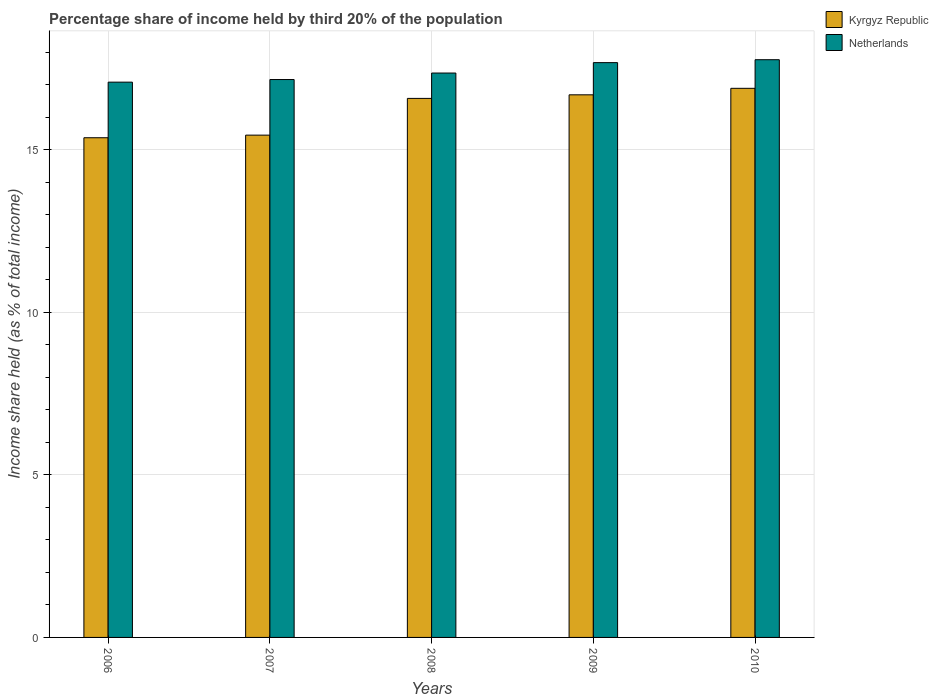How many different coloured bars are there?
Your answer should be very brief. 2. Are the number of bars per tick equal to the number of legend labels?
Provide a short and direct response. Yes. Are the number of bars on each tick of the X-axis equal?
Your answer should be compact. Yes. How many bars are there on the 2nd tick from the left?
Provide a short and direct response. 2. What is the share of income held by third 20% of the population in Netherlands in 2009?
Offer a very short reply. 17.68. Across all years, what is the maximum share of income held by third 20% of the population in Netherlands?
Offer a terse response. 17.77. Across all years, what is the minimum share of income held by third 20% of the population in Netherlands?
Provide a short and direct response. 17.08. In which year was the share of income held by third 20% of the population in Kyrgyz Republic maximum?
Provide a short and direct response. 2010. In which year was the share of income held by third 20% of the population in Kyrgyz Republic minimum?
Give a very brief answer. 2006. What is the total share of income held by third 20% of the population in Kyrgyz Republic in the graph?
Your answer should be very brief. 80.98. What is the difference between the share of income held by third 20% of the population in Netherlands in 2007 and that in 2009?
Keep it short and to the point. -0.52. What is the difference between the share of income held by third 20% of the population in Netherlands in 2007 and the share of income held by third 20% of the population in Kyrgyz Republic in 2006?
Provide a short and direct response. 1.79. What is the average share of income held by third 20% of the population in Kyrgyz Republic per year?
Offer a very short reply. 16.2. In the year 2010, what is the difference between the share of income held by third 20% of the population in Kyrgyz Republic and share of income held by third 20% of the population in Netherlands?
Provide a succinct answer. -0.88. What is the ratio of the share of income held by third 20% of the population in Kyrgyz Republic in 2007 to that in 2008?
Your answer should be compact. 0.93. Is the difference between the share of income held by third 20% of the population in Kyrgyz Republic in 2006 and 2009 greater than the difference between the share of income held by third 20% of the population in Netherlands in 2006 and 2009?
Give a very brief answer. No. What is the difference between the highest and the second highest share of income held by third 20% of the population in Kyrgyz Republic?
Provide a succinct answer. 0.2. What is the difference between the highest and the lowest share of income held by third 20% of the population in Netherlands?
Ensure brevity in your answer.  0.69. What does the 1st bar from the left in 2009 represents?
Offer a terse response. Kyrgyz Republic. How many bars are there?
Your answer should be compact. 10. How many years are there in the graph?
Ensure brevity in your answer.  5. Does the graph contain any zero values?
Your answer should be very brief. No. Does the graph contain grids?
Ensure brevity in your answer.  Yes. Where does the legend appear in the graph?
Give a very brief answer. Top right. How are the legend labels stacked?
Your response must be concise. Vertical. What is the title of the graph?
Offer a terse response. Percentage share of income held by third 20% of the population. Does "Samoa" appear as one of the legend labels in the graph?
Provide a succinct answer. No. What is the label or title of the X-axis?
Your answer should be very brief. Years. What is the label or title of the Y-axis?
Your answer should be very brief. Income share held (as % of total income). What is the Income share held (as % of total income) of Kyrgyz Republic in 2006?
Offer a terse response. 15.37. What is the Income share held (as % of total income) in Netherlands in 2006?
Your response must be concise. 17.08. What is the Income share held (as % of total income) of Kyrgyz Republic in 2007?
Keep it short and to the point. 15.45. What is the Income share held (as % of total income) of Netherlands in 2007?
Provide a succinct answer. 17.16. What is the Income share held (as % of total income) of Kyrgyz Republic in 2008?
Make the answer very short. 16.58. What is the Income share held (as % of total income) in Netherlands in 2008?
Give a very brief answer. 17.36. What is the Income share held (as % of total income) in Kyrgyz Republic in 2009?
Keep it short and to the point. 16.69. What is the Income share held (as % of total income) in Netherlands in 2009?
Your answer should be compact. 17.68. What is the Income share held (as % of total income) in Kyrgyz Republic in 2010?
Offer a terse response. 16.89. What is the Income share held (as % of total income) of Netherlands in 2010?
Offer a very short reply. 17.77. Across all years, what is the maximum Income share held (as % of total income) in Kyrgyz Republic?
Keep it short and to the point. 16.89. Across all years, what is the maximum Income share held (as % of total income) of Netherlands?
Your answer should be very brief. 17.77. Across all years, what is the minimum Income share held (as % of total income) in Kyrgyz Republic?
Ensure brevity in your answer.  15.37. Across all years, what is the minimum Income share held (as % of total income) of Netherlands?
Ensure brevity in your answer.  17.08. What is the total Income share held (as % of total income) in Kyrgyz Republic in the graph?
Offer a very short reply. 80.98. What is the total Income share held (as % of total income) of Netherlands in the graph?
Your answer should be compact. 87.05. What is the difference between the Income share held (as % of total income) of Kyrgyz Republic in 2006 and that in 2007?
Keep it short and to the point. -0.08. What is the difference between the Income share held (as % of total income) in Netherlands in 2006 and that in 2007?
Keep it short and to the point. -0.08. What is the difference between the Income share held (as % of total income) of Kyrgyz Republic in 2006 and that in 2008?
Keep it short and to the point. -1.21. What is the difference between the Income share held (as % of total income) of Netherlands in 2006 and that in 2008?
Offer a very short reply. -0.28. What is the difference between the Income share held (as % of total income) in Kyrgyz Republic in 2006 and that in 2009?
Provide a short and direct response. -1.32. What is the difference between the Income share held (as % of total income) of Kyrgyz Republic in 2006 and that in 2010?
Make the answer very short. -1.52. What is the difference between the Income share held (as % of total income) of Netherlands in 2006 and that in 2010?
Ensure brevity in your answer.  -0.69. What is the difference between the Income share held (as % of total income) in Kyrgyz Republic in 2007 and that in 2008?
Provide a short and direct response. -1.13. What is the difference between the Income share held (as % of total income) in Kyrgyz Republic in 2007 and that in 2009?
Your answer should be compact. -1.24. What is the difference between the Income share held (as % of total income) in Netherlands in 2007 and that in 2009?
Provide a short and direct response. -0.52. What is the difference between the Income share held (as % of total income) of Kyrgyz Republic in 2007 and that in 2010?
Offer a terse response. -1.44. What is the difference between the Income share held (as % of total income) of Netherlands in 2007 and that in 2010?
Your answer should be very brief. -0.61. What is the difference between the Income share held (as % of total income) in Kyrgyz Republic in 2008 and that in 2009?
Ensure brevity in your answer.  -0.11. What is the difference between the Income share held (as % of total income) in Netherlands in 2008 and that in 2009?
Make the answer very short. -0.32. What is the difference between the Income share held (as % of total income) in Kyrgyz Republic in 2008 and that in 2010?
Provide a short and direct response. -0.31. What is the difference between the Income share held (as % of total income) of Netherlands in 2008 and that in 2010?
Offer a terse response. -0.41. What is the difference between the Income share held (as % of total income) of Kyrgyz Republic in 2009 and that in 2010?
Offer a very short reply. -0.2. What is the difference between the Income share held (as % of total income) in Netherlands in 2009 and that in 2010?
Provide a short and direct response. -0.09. What is the difference between the Income share held (as % of total income) of Kyrgyz Republic in 2006 and the Income share held (as % of total income) of Netherlands in 2007?
Provide a short and direct response. -1.79. What is the difference between the Income share held (as % of total income) of Kyrgyz Republic in 2006 and the Income share held (as % of total income) of Netherlands in 2008?
Offer a very short reply. -1.99. What is the difference between the Income share held (as % of total income) in Kyrgyz Republic in 2006 and the Income share held (as % of total income) in Netherlands in 2009?
Your response must be concise. -2.31. What is the difference between the Income share held (as % of total income) in Kyrgyz Republic in 2006 and the Income share held (as % of total income) in Netherlands in 2010?
Keep it short and to the point. -2.4. What is the difference between the Income share held (as % of total income) of Kyrgyz Republic in 2007 and the Income share held (as % of total income) of Netherlands in 2008?
Offer a very short reply. -1.91. What is the difference between the Income share held (as % of total income) in Kyrgyz Republic in 2007 and the Income share held (as % of total income) in Netherlands in 2009?
Your answer should be very brief. -2.23. What is the difference between the Income share held (as % of total income) of Kyrgyz Republic in 2007 and the Income share held (as % of total income) of Netherlands in 2010?
Offer a terse response. -2.32. What is the difference between the Income share held (as % of total income) of Kyrgyz Republic in 2008 and the Income share held (as % of total income) of Netherlands in 2009?
Provide a short and direct response. -1.1. What is the difference between the Income share held (as % of total income) in Kyrgyz Republic in 2008 and the Income share held (as % of total income) in Netherlands in 2010?
Provide a succinct answer. -1.19. What is the difference between the Income share held (as % of total income) in Kyrgyz Republic in 2009 and the Income share held (as % of total income) in Netherlands in 2010?
Your response must be concise. -1.08. What is the average Income share held (as % of total income) of Kyrgyz Republic per year?
Provide a succinct answer. 16.2. What is the average Income share held (as % of total income) in Netherlands per year?
Your answer should be compact. 17.41. In the year 2006, what is the difference between the Income share held (as % of total income) in Kyrgyz Republic and Income share held (as % of total income) in Netherlands?
Your answer should be compact. -1.71. In the year 2007, what is the difference between the Income share held (as % of total income) in Kyrgyz Republic and Income share held (as % of total income) in Netherlands?
Your answer should be very brief. -1.71. In the year 2008, what is the difference between the Income share held (as % of total income) in Kyrgyz Republic and Income share held (as % of total income) in Netherlands?
Offer a terse response. -0.78. In the year 2009, what is the difference between the Income share held (as % of total income) of Kyrgyz Republic and Income share held (as % of total income) of Netherlands?
Your response must be concise. -0.99. In the year 2010, what is the difference between the Income share held (as % of total income) in Kyrgyz Republic and Income share held (as % of total income) in Netherlands?
Your answer should be compact. -0.88. What is the ratio of the Income share held (as % of total income) of Kyrgyz Republic in 2006 to that in 2007?
Provide a succinct answer. 0.99. What is the ratio of the Income share held (as % of total income) of Kyrgyz Republic in 2006 to that in 2008?
Provide a short and direct response. 0.93. What is the ratio of the Income share held (as % of total income) in Netherlands in 2006 to that in 2008?
Your answer should be very brief. 0.98. What is the ratio of the Income share held (as % of total income) in Kyrgyz Republic in 2006 to that in 2009?
Your answer should be very brief. 0.92. What is the ratio of the Income share held (as % of total income) of Netherlands in 2006 to that in 2009?
Your response must be concise. 0.97. What is the ratio of the Income share held (as % of total income) in Kyrgyz Republic in 2006 to that in 2010?
Your answer should be very brief. 0.91. What is the ratio of the Income share held (as % of total income) of Netherlands in 2006 to that in 2010?
Offer a very short reply. 0.96. What is the ratio of the Income share held (as % of total income) in Kyrgyz Republic in 2007 to that in 2008?
Offer a very short reply. 0.93. What is the ratio of the Income share held (as % of total income) in Netherlands in 2007 to that in 2008?
Your answer should be very brief. 0.99. What is the ratio of the Income share held (as % of total income) in Kyrgyz Republic in 2007 to that in 2009?
Offer a very short reply. 0.93. What is the ratio of the Income share held (as % of total income) in Netherlands in 2007 to that in 2009?
Provide a short and direct response. 0.97. What is the ratio of the Income share held (as % of total income) of Kyrgyz Republic in 2007 to that in 2010?
Your response must be concise. 0.91. What is the ratio of the Income share held (as % of total income) in Netherlands in 2007 to that in 2010?
Make the answer very short. 0.97. What is the ratio of the Income share held (as % of total income) in Kyrgyz Republic in 2008 to that in 2009?
Offer a terse response. 0.99. What is the ratio of the Income share held (as % of total income) in Netherlands in 2008 to that in 2009?
Your response must be concise. 0.98. What is the ratio of the Income share held (as % of total income) of Kyrgyz Republic in 2008 to that in 2010?
Ensure brevity in your answer.  0.98. What is the ratio of the Income share held (as % of total income) of Netherlands in 2008 to that in 2010?
Ensure brevity in your answer.  0.98. What is the difference between the highest and the second highest Income share held (as % of total income) in Netherlands?
Keep it short and to the point. 0.09. What is the difference between the highest and the lowest Income share held (as % of total income) in Kyrgyz Republic?
Give a very brief answer. 1.52. What is the difference between the highest and the lowest Income share held (as % of total income) in Netherlands?
Provide a succinct answer. 0.69. 